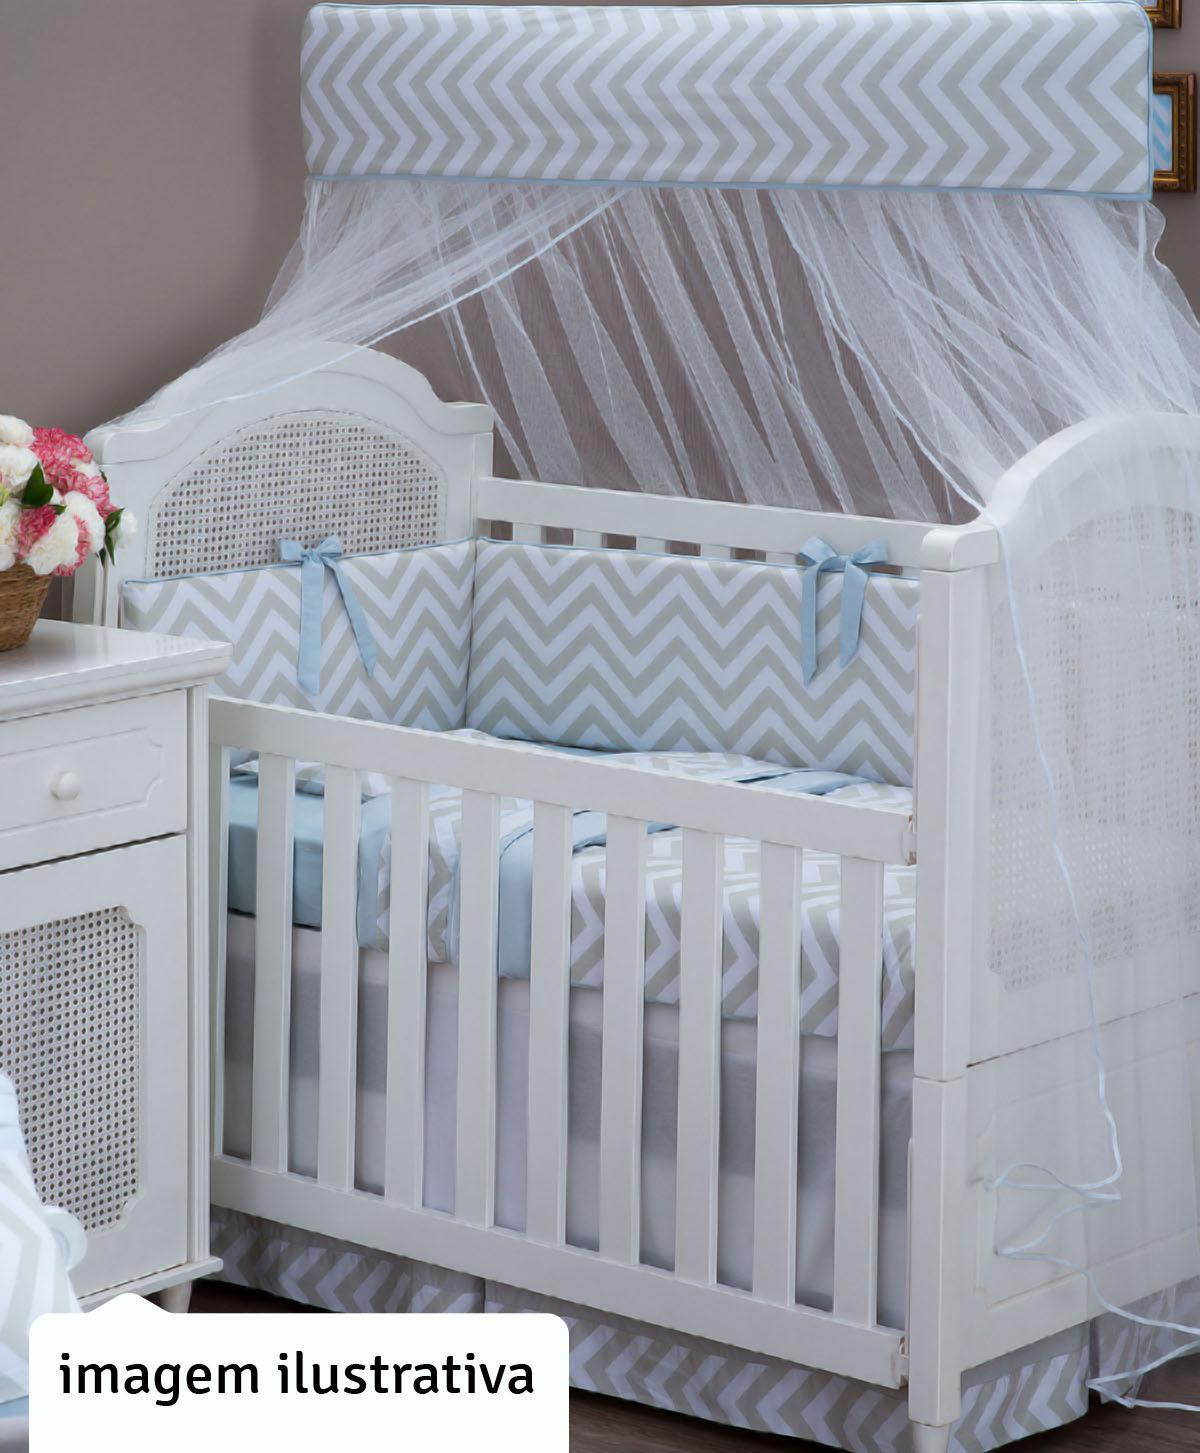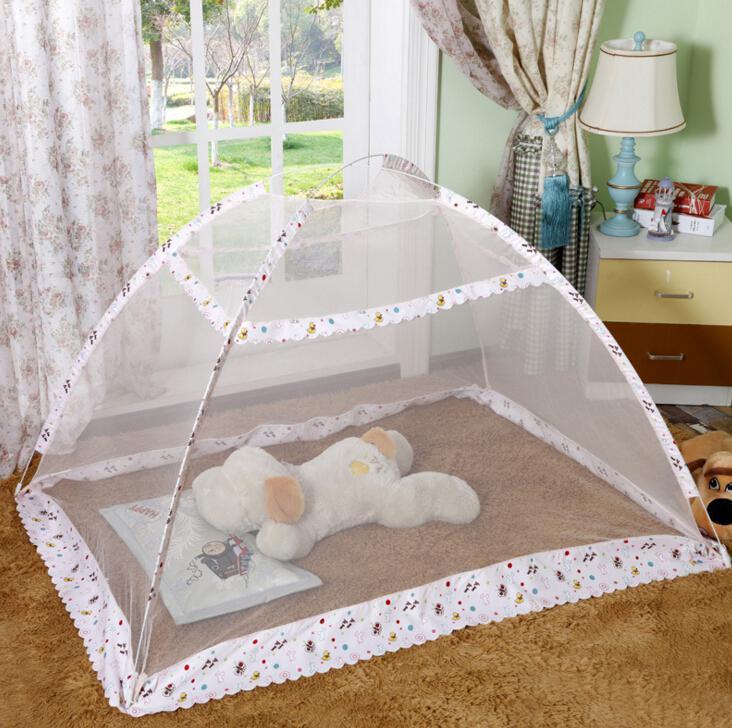The first image is the image on the left, the second image is the image on the right. For the images shown, is this caption "A tented net covers a sleeping area with a stuffed animal in the image on the right." true? Answer yes or no. Yes. The first image is the image on the left, the second image is the image on the right. Evaluate the accuracy of this statement regarding the images: "There are two canopies and at least one is a tent.". Is it true? Answer yes or no. Yes. 